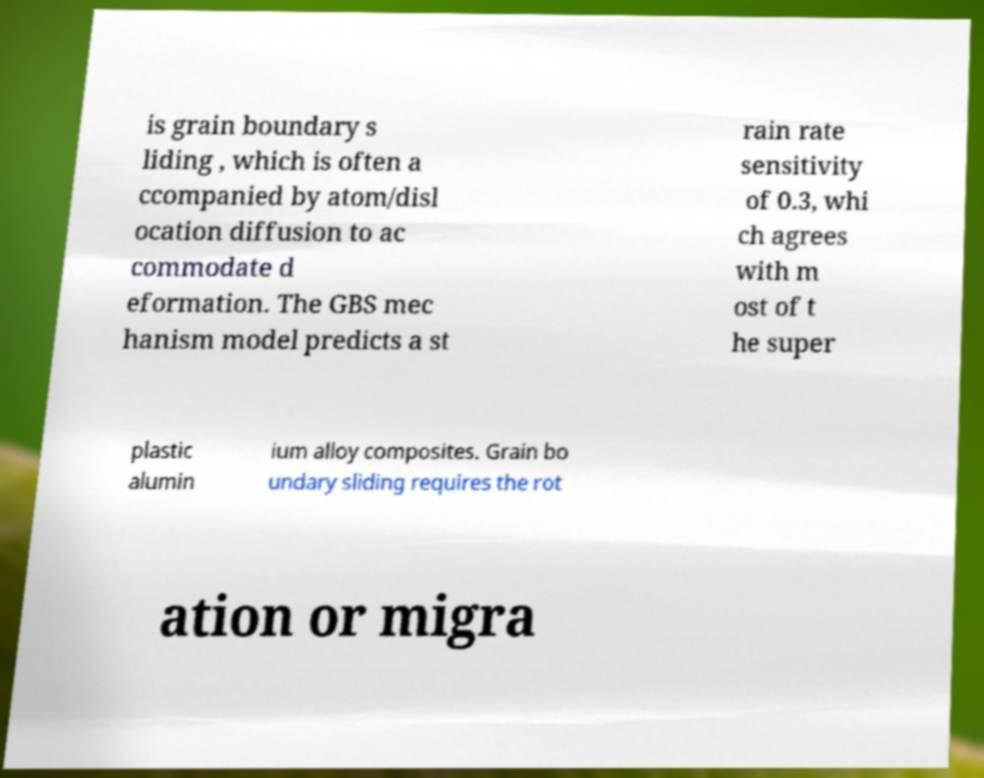I need the written content from this picture converted into text. Can you do that? is grain boundary s liding , which is often a ccompanied by atom/disl ocation diffusion to ac commodate d eformation. The GBS mec hanism model predicts a st rain rate sensitivity of 0.3, whi ch agrees with m ost of t he super plastic alumin ium alloy composites. Grain bo undary sliding requires the rot ation or migra 